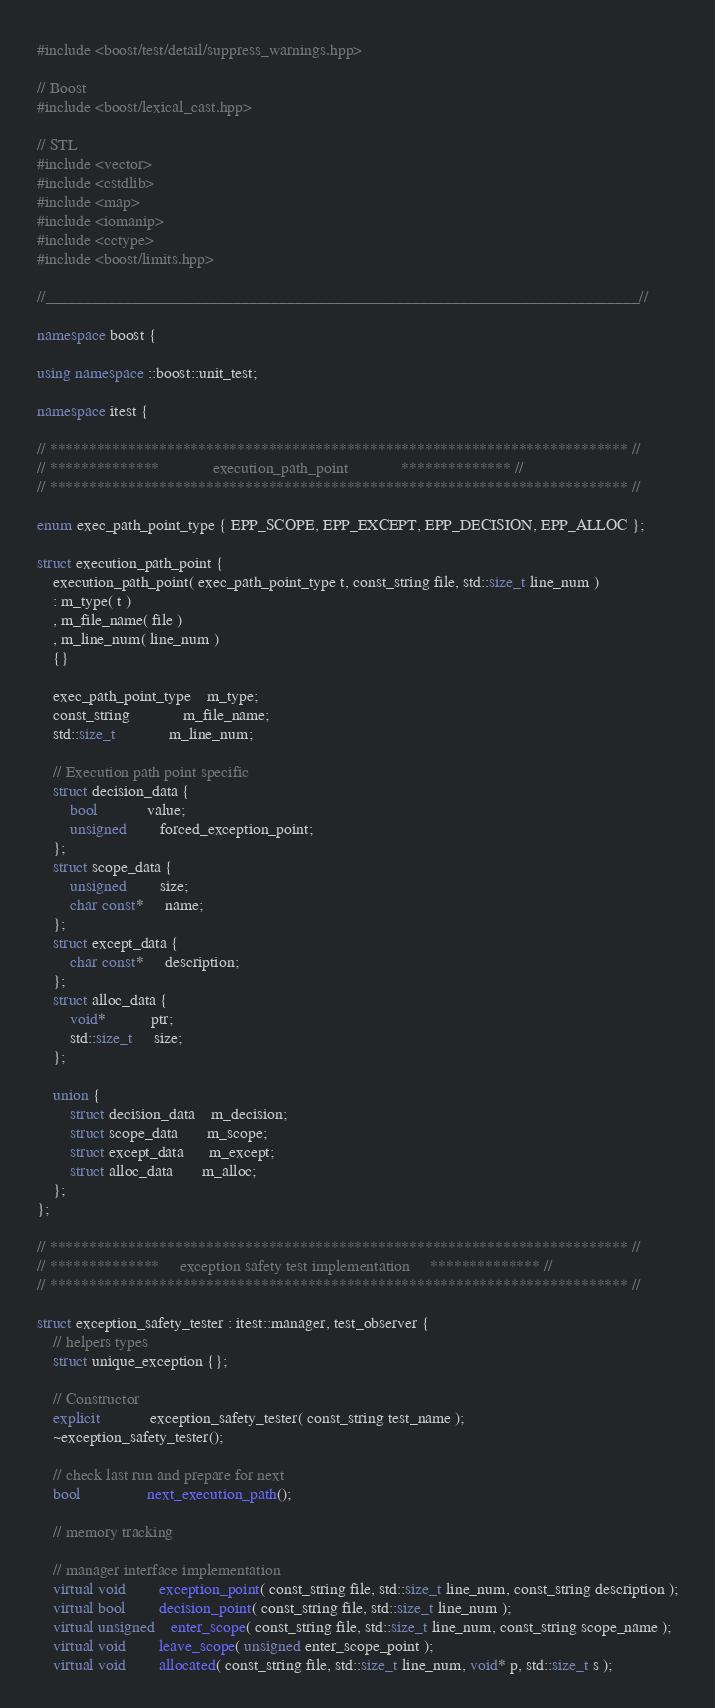Convert code to text. <code><loc_0><loc_0><loc_500><loc_500><_C++_>#include <boost/test/detail/suppress_warnings.hpp>

// Boost
#include <boost/lexical_cast.hpp>

// STL
#include <vector>
#include <cstdlib>
#include <map>
#include <iomanip>
#include <cctype>
#include <boost/limits.hpp>

//____________________________________________________________________________//

namespace boost {

using namespace ::boost::unit_test;
 
namespace itest {

// ************************************************************************** //
// **************             execution_path_point             ************** //
// ************************************************************************** //

enum exec_path_point_type { EPP_SCOPE, EPP_EXCEPT, EPP_DECISION, EPP_ALLOC };

struct execution_path_point {
    execution_path_point( exec_path_point_type t, const_string file, std::size_t line_num )
    : m_type( t )
    , m_file_name( file )
    , m_line_num( line_num )
    {}

    exec_path_point_type    m_type;
    const_string             m_file_name;
    std::size_t             m_line_num;

    // Execution path point specific
    struct decision_data {
        bool            value;
        unsigned        forced_exception_point;
    };
    struct scope_data {
        unsigned        size;
        char const*     name;
    };
    struct except_data {
        char const*     description;
    };
    struct alloc_data {
        void*           ptr;
        std::size_t     size;
    };

    union {
        struct decision_data    m_decision;
        struct scope_data       m_scope;
        struct except_data      m_except;
        struct alloc_data       m_alloc;
    };
};

// ************************************************************************** //
// **************     exception safety test implementation     ************** //
// ************************************************************************** //

struct exception_safety_tester : itest::manager, test_observer {
    // helpers types
    struct unique_exception {};

    // Constructor
    explicit            exception_safety_tester( const_string test_name );
    ~exception_safety_tester();

    // check last run and prepare for next
    bool                next_execution_path();

    // memory tracking

    // manager interface implementation
    virtual void        exception_point( const_string file, std::size_t line_num, const_string description );
    virtual bool        decision_point( const_string file, std::size_t line_num );
    virtual unsigned    enter_scope( const_string file, std::size_t line_num, const_string scope_name );
    virtual void        leave_scope( unsigned enter_scope_point );
    virtual void        allocated( const_string file, std::size_t line_num, void* p, std::size_t s );</code> 